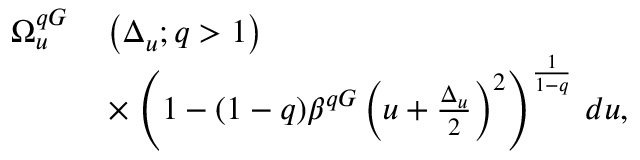Convert formula to latex. <formula><loc_0><loc_0><loc_500><loc_500>\begin{array} { r l } { \Omega _ { u } ^ { q G } } & \left ( \Delta _ { u } ; q > 1 \right ) } \\ { \quad } & \times \left ( 1 - ( 1 - q ) \beta ^ { q G } \left ( u + \frac { \Delta _ { u } } { 2 } \right ) ^ { 2 } \right ) ^ { \frac { 1 } { 1 - q } } \, d u , } \end{array}</formula> 